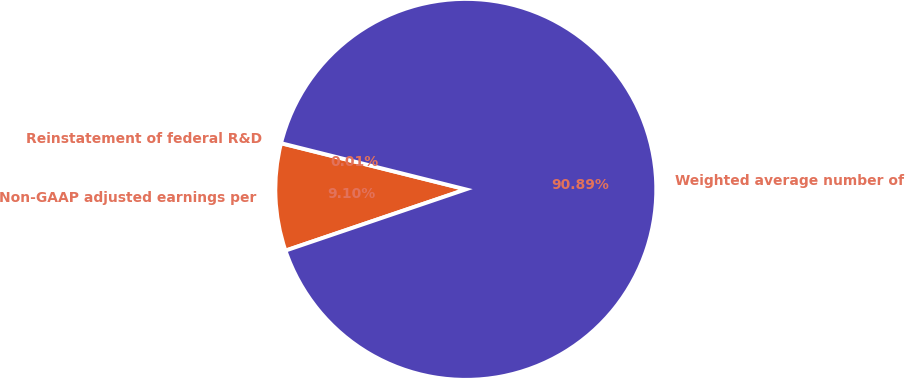<chart> <loc_0><loc_0><loc_500><loc_500><pie_chart><fcel>Reinstatement of federal R&D<fcel>Non-GAAP adjusted earnings per<fcel>Weighted average number of<nl><fcel>0.01%<fcel>9.1%<fcel>90.89%<nl></chart> 